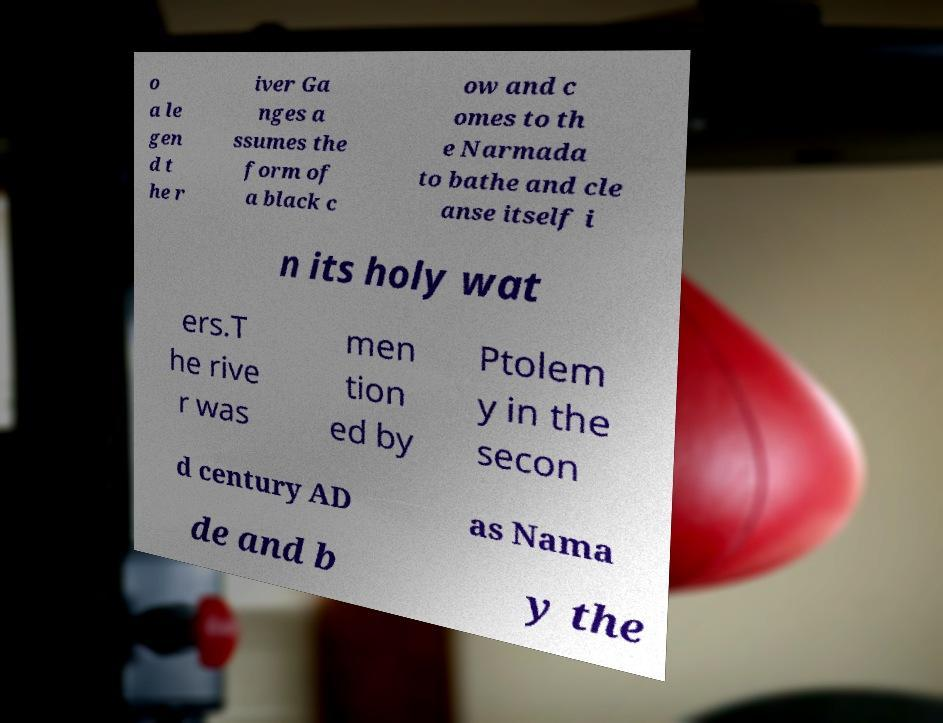There's text embedded in this image that I need extracted. Can you transcribe it verbatim? o a le gen d t he r iver Ga nges a ssumes the form of a black c ow and c omes to th e Narmada to bathe and cle anse itself i n its holy wat ers.T he rive r was men tion ed by Ptolem y in the secon d century AD as Nama de and b y the 